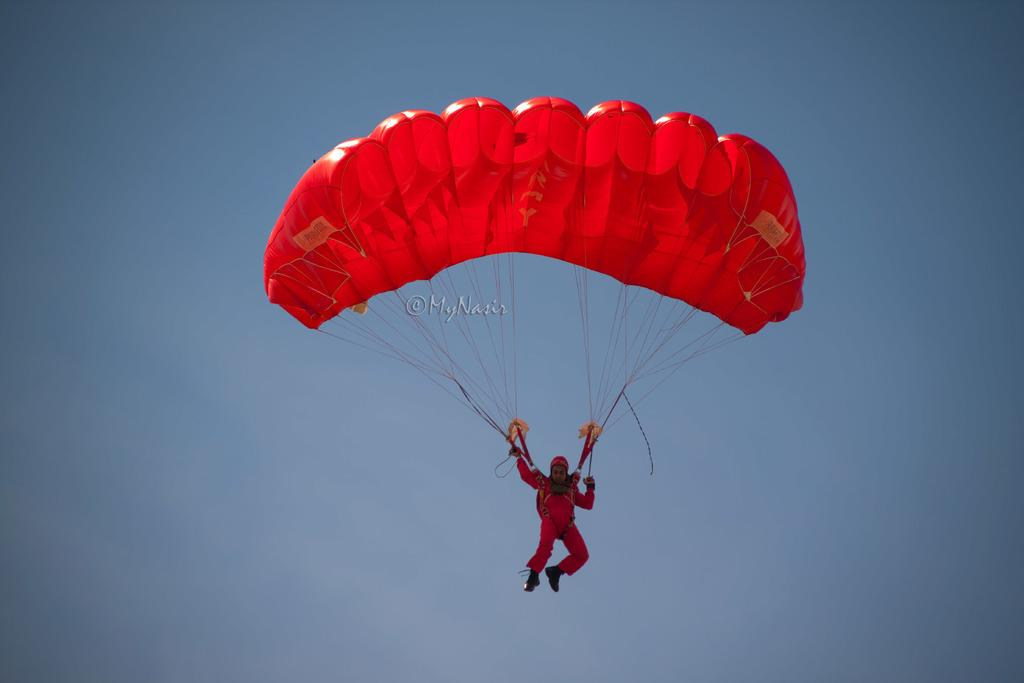What is happening to the person in the image? The person is flying in the air. How is the person flying in the air? The person is using a parachute. What color is the parachute? The parachute is red in color. What can be seen in the background of the image? The sky is visible in the background of the image. What is the color of the sky? The sky is blue in color. Where are the kittens playing in the image? There are no kittens present in the image. What type of board is being used by the person in the image? The person in the image is using a parachute, not a board. 